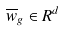<formula> <loc_0><loc_0><loc_500><loc_500>\overline { w } _ { g } \in R ^ { d }</formula> 